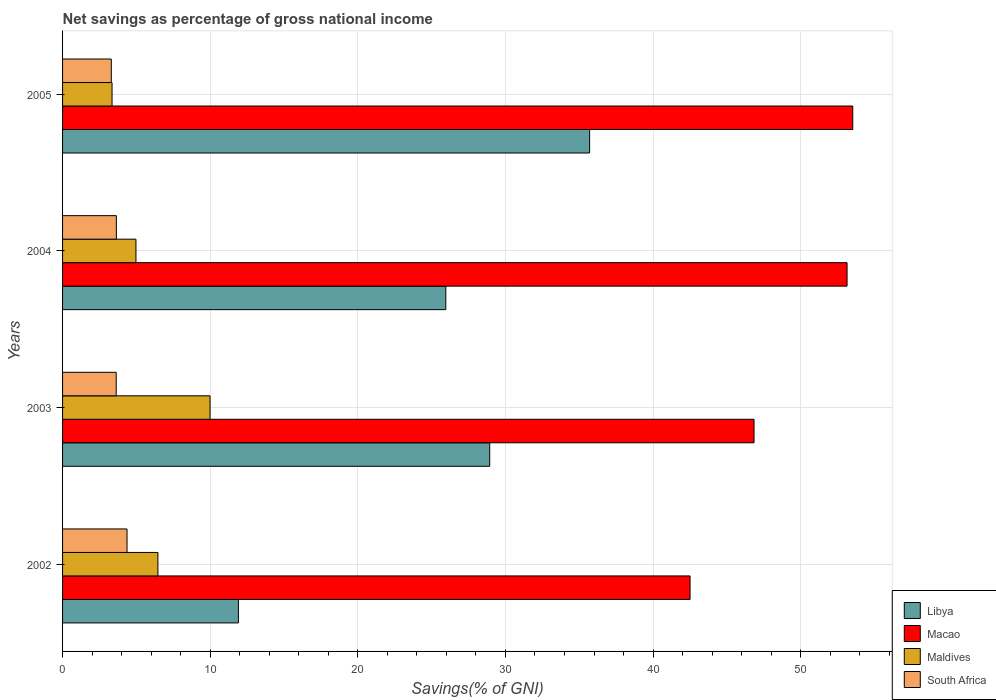How many different coloured bars are there?
Provide a succinct answer. 4. How many bars are there on the 1st tick from the top?
Keep it short and to the point. 4. What is the label of the 2nd group of bars from the top?
Make the answer very short. 2004. In how many cases, is the number of bars for a given year not equal to the number of legend labels?
Your answer should be very brief. 0. What is the total savings in South Africa in 2005?
Your answer should be compact. 3.3. Across all years, what is the maximum total savings in South Africa?
Your response must be concise. 4.37. Across all years, what is the minimum total savings in South Africa?
Offer a terse response. 3.3. What is the total total savings in Macao in the graph?
Provide a succinct answer. 196.02. What is the difference between the total savings in Libya in 2002 and that in 2005?
Provide a short and direct response. -23.79. What is the difference between the total savings in South Africa in 2003 and the total savings in Macao in 2002?
Provide a short and direct response. -38.87. What is the average total savings in Libya per year?
Provide a short and direct response. 25.63. In the year 2005, what is the difference between the total savings in Macao and total savings in South Africa?
Keep it short and to the point. 50.23. What is the ratio of the total savings in Libya in 2002 to that in 2005?
Make the answer very short. 0.33. Is the total savings in Libya in 2002 less than that in 2004?
Offer a terse response. Yes. Is the difference between the total savings in Macao in 2003 and 2005 greater than the difference between the total savings in South Africa in 2003 and 2005?
Offer a very short reply. No. What is the difference between the highest and the second highest total savings in Macao?
Give a very brief answer. 0.39. What is the difference between the highest and the lowest total savings in Macao?
Provide a succinct answer. 11.02. In how many years, is the total savings in Macao greater than the average total savings in Macao taken over all years?
Give a very brief answer. 2. Is the sum of the total savings in Macao in 2003 and 2004 greater than the maximum total savings in South Africa across all years?
Offer a very short reply. Yes. What does the 2nd bar from the top in 2004 represents?
Offer a very short reply. Maldives. What does the 2nd bar from the bottom in 2005 represents?
Provide a succinct answer. Macao. Is it the case that in every year, the sum of the total savings in Macao and total savings in Maldives is greater than the total savings in Libya?
Offer a very short reply. Yes. Are all the bars in the graph horizontal?
Ensure brevity in your answer.  Yes. Are the values on the major ticks of X-axis written in scientific E-notation?
Your answer should be very brief. No. Does the graph contain any zero values?
Make the answer very short. No. Where does the legend appear in the graph?
Your response must be concise. Bottom right. How are the legend labels stacked?
Offer a very short reply. Vertical. What is the title of the graph?
Offer a very short reply. Net savings as percentage of gross national income. What is the label or title of the X-axis?
Give a very brief answer. Savings(% of GNI). What is the label or title of the Y-axis?
Offer a very short reply. Years. What is the Savings(% of GNI) in Libya in 2002?
Ensure brevity in your answer.  11.91. What is the Savings(% of GNI) of Macao in 2002?
Your answer should be compact. 42.51. What is the Savings(% of GNI) of Maldives in 2002?
Give a very brief answer. 6.46. What is the Savings(% of GNI) in South Africa in 2002?
Ensure brevity in your answer.  4.37. What is the Savings(% of GNI) of Libya in 2003?
Make the answer very short. 28.94. What is the Savings(% of GNI) in Macao in 2003?
Keep it short and to the point. 46.84. What is the Savings(% of GNI) in Maldives in 2003?
Keep it short and to the point. 9.99. What is the Savings(% of GNI) in South Africa in 2003?
Offer a very short reply. 3.63. What is the Savings(% of GNI) of Libya in 2004?
Provide a succinct answer. 25.96. What is the Savings(% of GNI) of Macao in 2004?
Your answer should be very brief. 53.14. What is the Savings(% of GNI) in Maldives in 2004?
Give a very brief answer. 4.97. What is the Savings(% of GNI) of South Africa in 2004?
Provide a succinct answer. 3.64. What is the Savings(% of GNI) of Libya in 2005?
Your response must be concise. 35.7. What is the Savings(% of GNI) in Macao in 2005?
Give a very brief answer. 53.53. What is the Savings(% of GNI) in Maldives in 2005?
Your answer should be very brief. 3.35. What is the Savings(% of GNI) in South Africa in 2005?
Make the answer very short. 3.3. Across all years, what is the maximum Savings(% of GNI) in Libya?
Offer a terse response. 35.7. Across all years, what is the maximum Savings(% of GNI) of Macao?
Offer a very short reply. 53.53. Across all years, what is the maximum Savings(% of GNI) in Maldives?
Your answer should be very brief. 9.99. Across all years, what is the maximum Savings(% of GNI) of South Africa?
Provide a succinct answer. 4.37. Across all years, what is the minimum Savings(% of GNI) of Libya?
Your answer should be very brief. 11.91. Across all years, what is the minimum Savings(% of GNI) in Macao?
Give a very brief answer. 42.51. Across all years, what is the minimum Savings(% of GNI) in Maldives?
Offer a very short reply. 3.35. Across all years, what is the minimum Savings(% of GNI) of South Africa?
Your answer should be very brief. 3.3. What is the total Savings(% of GNI) of Libya in the graph?
Offer a terse response. 102.51. What is the total Savings(% of GNI) of Macao in the graph?
Give a very brief answer. 196.02. What is the total Savings(% of GNI) in Maldives in the graph?
Provide a succinct answer. 24.77. What is the total Savings(% of GNI) of South Africa in the graph?
Your response must be concise. 14.94. What is the difference between the Savings(% of GNI) in Libya in 2002 and that in 2003?
Offer a very short reply. -17.02. What is the difference between the Savings(% of GNI) in Macao in 2002 and that in 2003?
Offer a very short reply. -4.33. What is the difference between the Savings(% of GNI) of Maldives in 2002 and that in 2003?
Provide a short and direct response. -3.53. What is the difference between the Savings(% of GNI) of South Africa in 2002 and that in 2003?
Your response must be concise. 0.73. What is the difference between the Savings(% of GNI) of Libya in 2002 and that in 2004?
Provide a succinct answer. -14.05. What is the difference between the Savings(% of GNI) in Macao in 2002 and that in 2004?
Your response must be concise. -10.63. What is the difference between the Savings(% of GNI) in Maldives in 2002 and that in 2004?
Offer a very short reply. 1.49. What is the difference between the Savings(% of GNI) of South Africa in 2002 and that in 2004?
Offer a terse response. 0.72. What is the difference between the Savings(% of GNI) in Libya in 2002 and that in 2005?
Your answer should be compact. -23.79. What is the difference between the Savings(% of GNI) of Macao in 2002 and that in 2005?
Offer a very short reply. -11.02. What is the difference between the Savings(% of GNI) in Maldives in 2002 and that in 2005?
Make the answer very short. 3.11. What is the difference between the Savings(% of GNI) in South Africa in 2002 and that in 2005?
Keep it short and to the point. 1.07. What is the difference between the Savings(% of GNI) in Libya in 2003 and that in 2004?
Give a very brief answer. 2.97. What is the difference between the Savings(% of GNI) in Macao in 2003 and that in 2004?
Keep it short and to the point. -6.3. What is the difference between the Savings(% of GNI) of Maldives in 2003 and that in 2004?
Your answer should be compact. 5.02. What is the difference between the Savings(% of GNI) in South Africa in 2003 and that in 2004?
Give a very brief answer. -0.01. What is the difference between the Savings(% of GNI) in Libya in 2003 and that in 2005?
Make the answer very short. -6.77. What is the difference between the Savings(% of GNI) in Macao in 2003 and that in 2005?
Offer a very short reply. -6.69. What is the difference between the Savings(% of GNI) in Maldives in 2003 and that in 2005?
Your answer should be compact. 6.64. What is the difference between the Savings(% of GNI) in South Africa in 2003 and that in 2005?
Your answer should be compact. 0.33. What is the difference between the Savings(% of GNI) in Libya in 2004 and that in 2005?
Your answer should be compact. -9.74. What is the difference between the Savings(% of GNI) of Macao in 2004 and that in 2005?
Your answer should be very brief. -0.39. What is the difference between the Savings(% of GNI) of Maldives in 2004 and that in 2005?
Your answer should be very brief. 1.62. What is the difference between the Savings(% of GNI) of South Africa in 2004 and that in 2005?
Offer a terse response. 0.34. What is the difference between the Savings(% of GNI) of Libya in 2002 and the Savings(% of GNI) of Macao in 2003?
Provide a succinct answer. -34.93. What is the difference between the Savings(% of GNI) in Libya in 2002 and the Savings(% of GNI) in Maldives in 2003?
Keep it short and to the point. 1.92. What is the difference between the Savings(% of GNI) in Libya in 2002 and the Savings(% of GNI) in South Africa in 2003?
Provide a succinct answer. 8.28. What is the difference between the Savings(% of GNI) of Macao in 2002 and the Savings(% of GNI) of Maldives in 2003?
Provide a short and direct response. 32.52. What is the difference between the Savings(% of GNI) of Macao in 2002 and the Savings(% of GNI) of South Africa in 2003?
Give a very brief answer. 38.87. What is the difference between the Savings(% of GNI) in Maldives in 2002 and the Savings(% of GNI) in South Africa in 2003?
Provide a succinct answer. 2.83. What is the difference between the Savings(% of GNI) of Libya in 2002 and the Savings(% of GNI) of Macao in 2004?
Make the answer very short. -41.23. What is the difference between the Savings(% of GNI) in Libya in 2002 and the Savings(% of GNI) in Maldives in 2004?
Provide a succinct answer. 6.94. What is the difference between the Savings(% of GNI) in Libya in 2002 and the Savings(% of GNI) in South Africa in 2004?
Make the answer very short. 8.27. What is the difference between the Savings(% of GNI) of Macao in 2002 and the Savings(% of GNI) of Maldives in 2004?
Provide a succinct answer. 37.54. What is the difference between the Savings(% of GNI) of Macao in 2002 and the Savings(% of GNI) of South Africa in 2004?
Make the answer very short. 38.86. What is the difference between the Savings(% of GNI) in Maldives in 2002 and the Savings(% of GNI) in South Africa in 2004?
Ensure brevity in your answer.  2.82. What is the difference between the Savings(% of GNI) of Libya in 2002 and the Savings(% of GNI) of Macao in 2005?
Your response must be concise. -41.62. What is the difference between the Savings(% of GNI) in Libya in 2002 and the Savings(% of GNI) in Maldives in 2005?
Offer a terse response. 8.56. What is the difference between the Savings(% of GNI) in Libya in 2002 and the Savings(% of GNI) in South Africa in 2005?
Ensure brevity in your answer.  8.61. What is the difference between the Savings(% of GNI) in Macao in 2002 and the Savings(% of GNI) in Maldives in 2005?
Keep it short and to the point. 39.16. What is the difference between the Savings(% of GNI) of Macao in 2002 and the Savings(% of GNI) of South Africa in 2005?
Make the answer very short. 39.21. What is the difference between the Savings(% of GNI) of Maldives in 2002 and the Savings(% of GNI) of South Africa in 2005?
Your answer should be very brief. 3.16. What is the difference between the Savings(% of GNI) in Libya in 2003 and the Savings(% of GNI) in Macao in 2004?
Offer a terse response. -24.21. What is the difference between the Savings(% of GNI) of Libya in 2003 and the Savings(% of GNI) of Maldives in 2004?
Provide a succinct answer. 23.96. What is the difference between the Savings(% of GNI) in Libya in 2003 and the Savings(% of GNI) in South Africa in 2004?
Offer a terse response. 25.29. What is the difference between the Savings(% of GNI) in Macao in 2003 and the Savings(% of GNI) in Maldives in 2004?
Give a very brief answer. 41.87. What is the difference between the Savings(% of GNI) of Macao in 2003 and the Savings(% of GNI) of South Africa in 2004?
Ensure brevity in your answer.  43.2. What is the difference between the Savings(% of GNI) in Maldives in 2003 and the Savings(% of GNI) in South Africa in 2004?
Make the answer very short. 6.35. What is the difference between the Savings(% of GNI) in Libya in 2003 and the Savings(% of GNI) in Macao in 2005?
Keep it short and to the point. -24.59. What is the difference between the Savings(% of GNI) of Libya in 2003 and the Savings(% of GNI) of Maldives in 2005?
Offer a very short reply. 25.58. What is the difference between the Savings(% of GNI) of Libya in 2003 and the Savings(% of GNI) of South Africa in 2005?
Offer a very short reply. 25.63. What is the difference between the Savings(% of GNI) of Macao in 2003 and the Savings(% of GNI) of Maldives in 2005?
Make the answer very short. 43.49. What is the difference between the Savings(% of GNI) of Macao in 2003 and the Savings(% of GNI) of South Africa in 2005?
Provide a succinct answer. 43.54. What is the difference between the Savings(% of GNI) in Maldives in 2003 and the Savings(% of GNI) in South Africa in 2005?
Make the answer very short. 6.69. What is the difference between the Savings(% of GNI) in Libya in 2004 and the Savings(% of GNI) in Macao in 2005?
Give a very brief answer. -27.57. What is the difference between the Savings(% of GNI) of Libya in 2004 and the Savings(% of GNI) of Maldives in 2005?
Ensure brevity in your answer.  22.61. What is the difference between the Savings(% of GNI) of Libya in 2004 and the Savings(% of GNI) of South Africa in 2005?
Provide a succinct answer. 22.66. What is the difference between the Savings(% of GNI) of Macao in 2004 and the Savings(% of GNI) of Maldives in 2005?
Offer a very short reply. 49.79. What is the difference between the Savings(% of GNI) in Macao in 2004 and the Savings(% of GNI) in South Africa in 2005?
Offer a terse response. 49.84. What is the difference between the Savings(% of GNI) in Maldives in 2004 and the Savings(% of GNI) in South Africa in 2005?
Ensure brevity in your answer.  1.67. What is the average Savings(% of GNI) of Libya per year?
Your response must be concise. 25.63. What is the average Savings(% of GNI) in Macao per year?
Offer a very short reply. 49. What is the average Savings(% of GNI) in Maldives per year?
Keep it short and to the point. 6.19. What is the average Savings(% of GNI) of South Africa per year?
Offer a terse response. 3.74. In the year 2002, what is the difference between the Savings(% of GNI) of Libya and Savings(% of GNI) of Macao?
Keep it short and to the point. -30.59. In the year 2002, what is the difference between the Savings(% of GNI) of Libya and Savings(% of GNI) of Maldives?
Your answer should be compact. 5.45. In the year 2002, what is the difference between the Savings(% of GNI) of Libya and Savings(% of GNI) of South Africa?
Your answer should be very brief. 7.55. In the year 2002, what is the difference between the Savings(% of GNI) of Macao and Savings(% of GNI) of Maldives?
Offer a terse response. 36.05. In the year 2002, what is the difference between the Savings(% of GNI) in Macao and Savings(% of GNI) in South Africa?
Ensure brevity in your answer.  38.14. In the year 2002, what is the difference between the Savings(% of GNI) of Maldives and Savings(% of GNI) of South Africa?
Offer a terse response. 2.09. In the year 2003, what is the difference between the Savings(% of GNI) in Libya and Savings(% of GNI) in Macao?
Your answer should be compact. -17.91. In the year 2003, what is the difference between the Savings(% of GNI) in Libya and Savings(% of GNI) in Maldives?
Offer a terse response. 18.94. In the year 2003, what is the difference between the Savings(% of GNI) in Libya and Savings(% of GNI) in South Africa?
Make the answer very short. 25.3. In the year 2003, what is the difference between the Savings(% of GNI) of Macao and Savings(% of GNI) of Maldives?
Give a very brief answer. 36.85. In the year 2003, what is the difference between the Savings(% of GNI) in Macao and Savings(% of GNI) in South Africa?
Give a very brief answer. 43.21. In the year 2003, what is the difference between the Savings(% of GNI) of Maldives and Savings(% of GNI) of South Africa?
Keep it short and to the point. 6.36. In the year 2004, what is the difference between the Savings(% of GNI) of Libya and Savings(% of GNI) of Macao?
Provide a short and direct response. -27.18. In the year 2004, what is the difference between the Savings(% of GNI) of Libya and Savings(% of GNI) of Maldives?
Offer a terse response. 20.99. In the year 2004, what is the difference between the Savings(% of GNI) in Libya and Savings(% of GNI) in South Africa?
Provide a succinct answer. 22.32. In the year 2004, what is the difference between the Savings(% of GNI) of Macao and Savings(% of GNI) of Maldives?
Keep it short and to the point. 48.17. In the year 2004, what is the difference between the Savings(% of GNI) of Macao and Savings(% of GNI) of South Africa?
Offer a very short reply. 49.5. In the year 2004, what is the difference between the Savings(% of GNI) of Maldives and Savings(% of GNI) of South Africa?
Keep it short and to the point. 1.33. In the year 2005, what is the difference between the Savings(% of GNI) of Libya and Savings(% of GNI) of Macao?
Offer a very short reply. -17.83. In the year 2005, what is the difference between the Savings(% of GNI) of Libya and Savings(% of GNI) of Maldives?
Ensure brevity in your answer.  32.35. In the year 2005, what is the difference between the Savings(% of GNI) of Libya and Savings(% of GNI) of South Africa?
Your answer should be compact. 32.4. In the year 2005, what is the difference between the Savings(% of GNI) in Macao and Savings(% of GNI) in Maldives?
Offer a terse response. 50.18. In the year 2005, what is the difference between the Savings(% of GNI) in Macao and Savings(% of GNI) in South Africa?
Your response must be concise. 50.23. In the year 2005, what is the difference between the Savings(% of GNI) in Maldives and Savings(% of GNI) in South Africa?
Offer a very short reply. 0.05. What is the ratio of the Savings(% of GNI) of Libya in 2002 to that in 2003?
Your answer should be compact. 0.41. What is the ratio of the Savings(% of GNI) of Macao in 2002 to that in 2003?
Make the answer very short. 0.91. What is the ratio of the Savings(% of GNI) in Maldives in 2002 to that in 2003?
Your response must be concise. 0.65. What is the ratio of the Savings(% of GNI) in South Africa in 2002 to that in 2003?
Provide a succinct answer. 1.2. What is the ratio of the Savings(% of GNI) in Libya in 2002 to that in 2004?
Ensure brevity in your answer.  0.46. What is the ratio of the Savings(% of GNI) in Macao in 2002 to that in 2004?
Give a very brief answer. 0.8. What is the ratio of the Savings(% of GNI) of Maldives in 2002 to that in 2004?
Keep it short and to the point. 1.3. What is the ratio of the Savings(% of GNI) of South Africa in 2002 to that in 2004?
Offer a very short reply. 1.2. What is the ratio of the Savings(% of GNI) of Libya in 2002 to that in 2005?
Provide a short and direct response. 0.33. What is the ratio of the Savings(% of GNI) of Macao in 2002 to that in 2005?
Provide a succinct answer. 0.79. What is the ratio of the Savings(% of GNI) of Maldives in 2002 to that in 2005?
Provide a short and direct response. 1.93. What is the ratio of the Savings(% of GNI) in South Africa in 2002 to that in 2005?
Give a very brief answer. 1.32. What is the ratio of the Savings(% of GNI) in Libya in 2003 to that in 2004?
Offer a very short reply. 1.11. What is the ratio of the Savings(% of GNI) of Macao in 2003 to that in 2004?
Provide a succinct answer. 0.88. What is the ratio of the Savings(% of GNI) in Maldives in 2003 to that in 2004?
Your answer should be compact. 2.01. What is the ratio of the Savings(% of GNI) of South Africa in 2003 to that in 2004?
Offer a terse response. 1. What is the ratio of the Savings(% of GNI) of Libya in 2003 to that in 2005?
Your response must be concise. 0.81. What is the ratio of the Savings(% of GNI) of Macao in 2003 to that in 2005?
Provide a short and direct response. 0.88. What is the ratio of the Savings(% of GNI) in Maldives in 2003 to that in 2005?
Give a very brief answer. 2.98. What is the ratio of the Savings(% of GNI) in South Africa in 2003 to that in 2005?
Your answer should be very brief. 1.1. What is the ratio of the Savings(% of GNI) in Libya in 2004 to that in 2005?
Your answer should be compact. 0.73. What is the ratio of the Savings(% of GNI) in Maldives in 2004 to that in 2005?
Your response must be concise. 1.48. What is the ratio of the Savings(% of GNI) in South Africa in 2004 to that in 2005?
Offer a terse response. 1.1. What is the difference between the highest and the second highest Savings(% of GNI) in Libya?
Provide a short and direct response. 6.77. What is the difference between the highest and the second highest Savings(% of GNI) of Macao?
Make the answer very short. 0.39. What is the difference between the highest and the second highest Savings(% of GNI) in Maldives?
Ensure brevity in your answer.  3.53. What is the difference between the highest and the second highest Savings(% of GNI) in South Africa?
Your answer should be very brief. 0.72. What is the difference between the highest and the lowest Savings(% of GNI) of Libya?
Give a very brief answer. 23.79. What is the difference between the highest and the lowest Savings(% of GNI) of Macao?
Your answer should be compact. 11.02. What is the difference between the highest and the lowest Savings(% of GNI) in Maldives?
Give a very brief answer. 6.64. What is the difference between the highest and the lowest Savings(% of GNI) in South Africa?
Offer a very short reply. 1.07. 